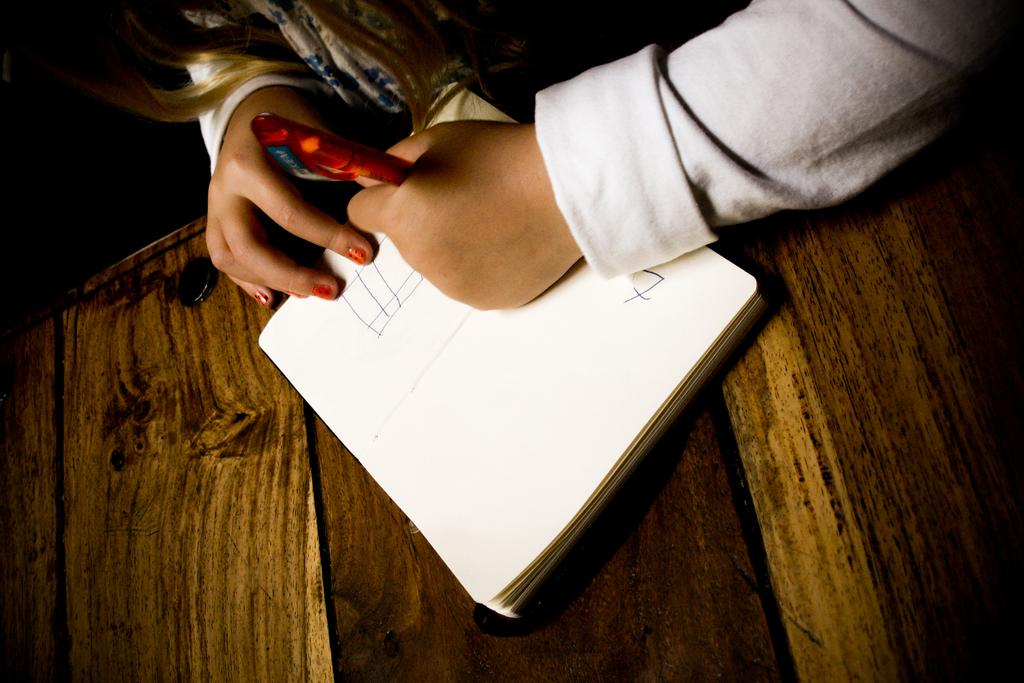What is the main object in the center of the image? There is a table in the center of the image. What is placed on the table? A book is present on the table. What is the person doing with the book? The person is writing on the book. What tool is the person using to write? The person is using a pen to write. What type of wheel is visible in the image? There is no wheel present in the image. What room is the person in while writing on the book? The provided facts do not specify the room or location where the person is writing on the book. 